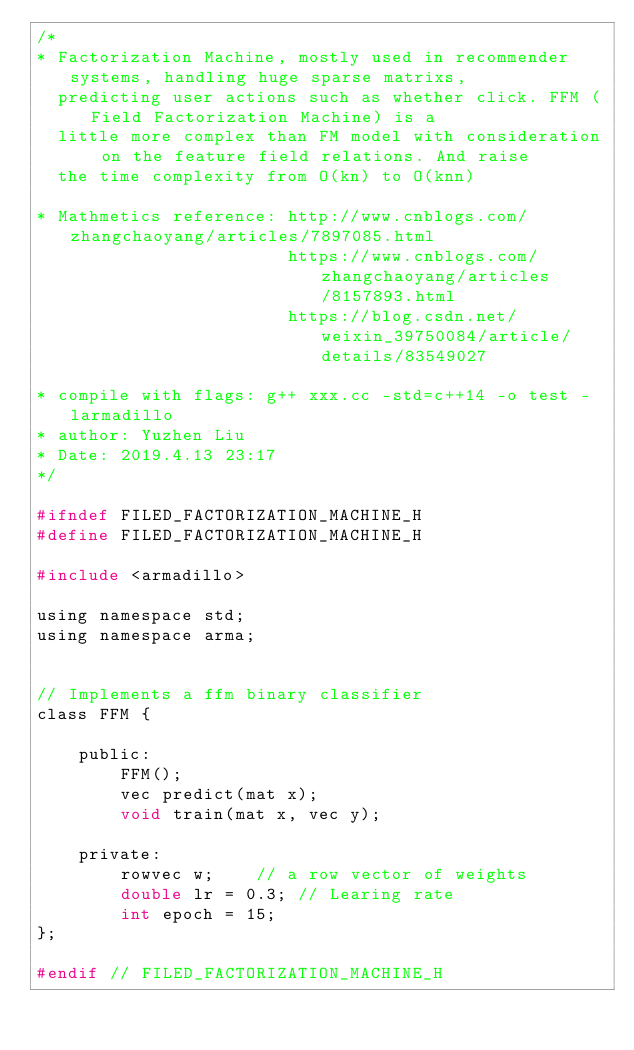Convert code to text. <code><loc_0><loc_0><loc_500><loc_500><_C_>/*
* Factorization Machine, mostly used in recommender systems, handling huge sparse matrixs, 
  predicting user actions such as whether click. FFM (Field Factorization Machine) is a 
  little more complex than FM model with consideration on the feature field relations. And raise 
  the time complexity from O(kn) to O(knn)

* Mathmetics reference: http://www.cnblogs.com/zhangchaoyang/articles/7897085.html
                        https://www.cnblogs.com/zhangchaoyang/articles/8157893.html
                        https://blog.csdn.net/weixin_39750084/article/details/83549027
                        
* compile with flags: g++ xxx.cc -std=c++14 -o test -larmadillo
* author: Yuzhen Liu
* Date: 2019.4.13 23:17
*/

#ifndef FILED_FACTORIZATION_MACHINE_H
#define FILED_FACTORIZATION_MACHINE_H

#include <armadillo>

using namespace std;
using namespace arma;


// Implements a ffm binary classifier
class FFM {

    public:
        FFM();
        vec predict(mat x);
        void train(mat x, vec y);

    private:
        rowvec w;    // a row vector of weights
        double lr = 0.3; // Learing rate
        int epoch = 15;
};

#endif // FILED_FACTORIZATION_MACHINE_H</code> 